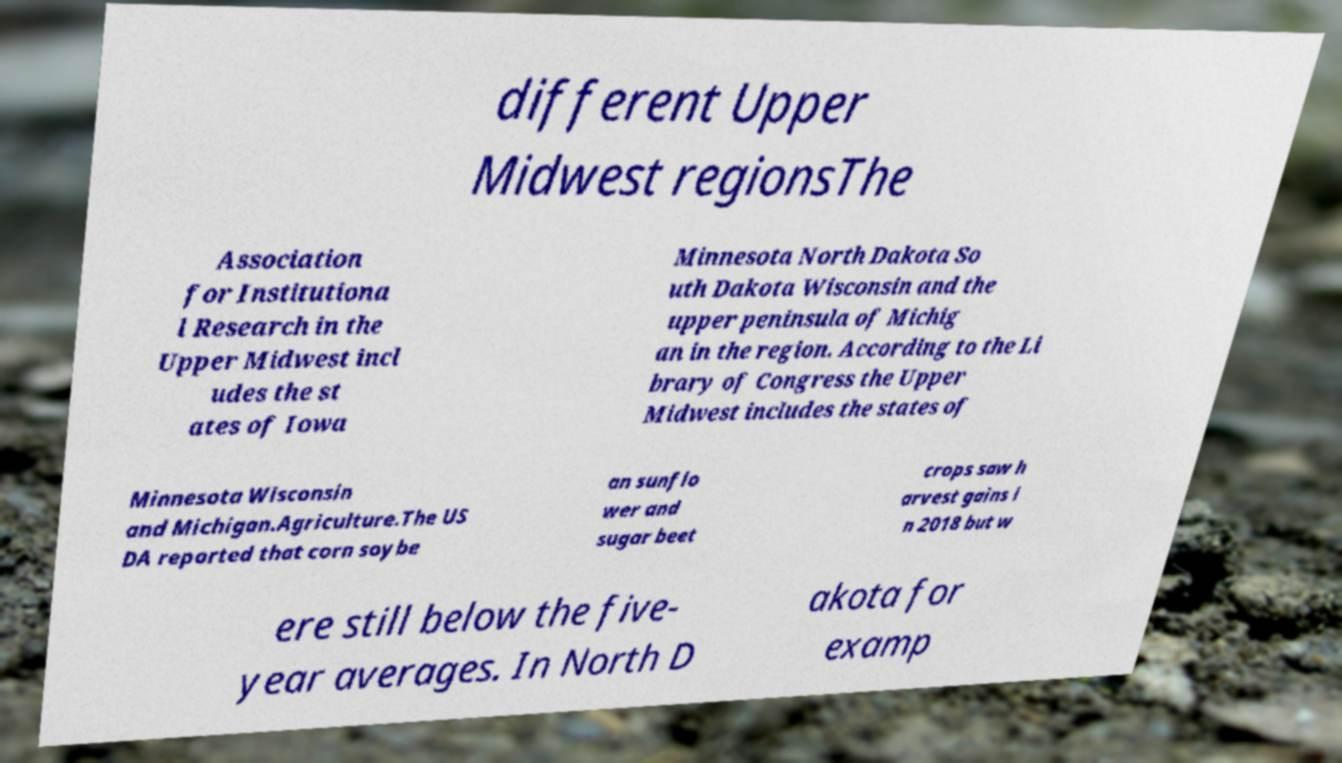For documentation purposes, I need the text within this image transcribed. Could you provide that? different Upper Midwest regionsThe Association for Institutiona l Research in the Upper Midwest incl udes the st ates of Iowa Minnesota North Dakota So uth Dakota Wisconsin and the upper peninsula of Michig an in the region. According to the Li brary of Congress the Upper Midwest includes the states of Minnesota Wisconsin and Michigan.Agriculture.The US DA reported that corn soybe an sunflo wer and sugar beet crops saw h arvest gains i n 2018 but w ere still below the five- year averages. In North D akota for examp 